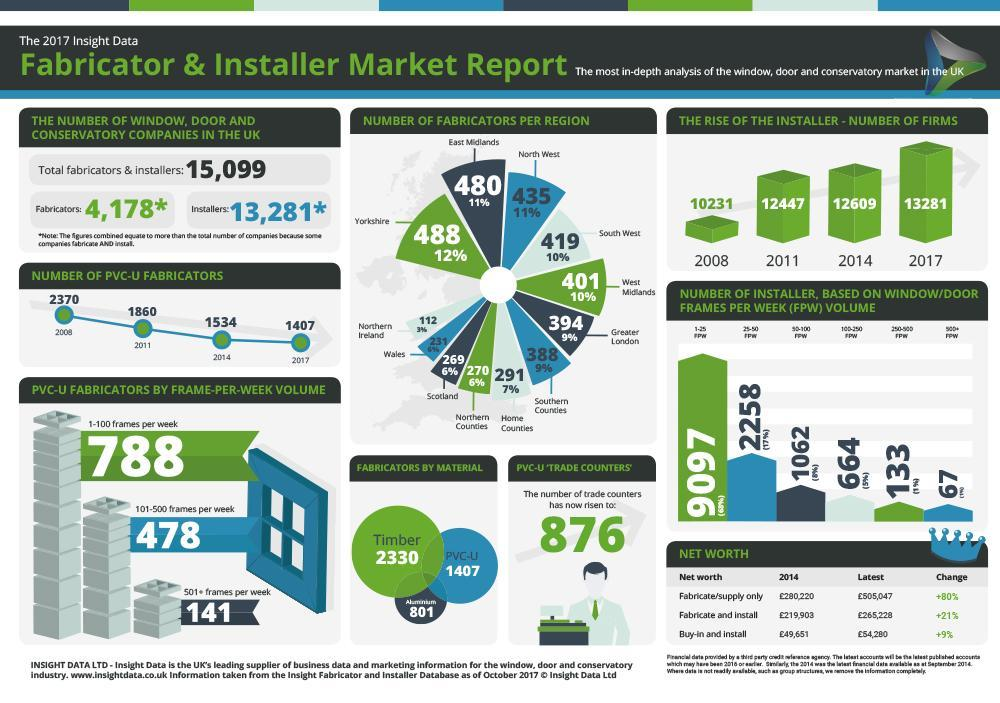By what number did PVC-U fabricators drop from 2011 to 2017?
Answer the question with a short phrase. 453 Which material is used most commonly fabricators? Timber How many fabricators are there in East Midlands and North West 915 By what number did installer-number of firms increase from 2008 to 2017? 3,050 How many fabricators work on more than 500 frames per week? 141 What percent of fabricators are there in Greater London and Southern Counties? 18% Which region has the highest number of fabricators? Yorkshire 